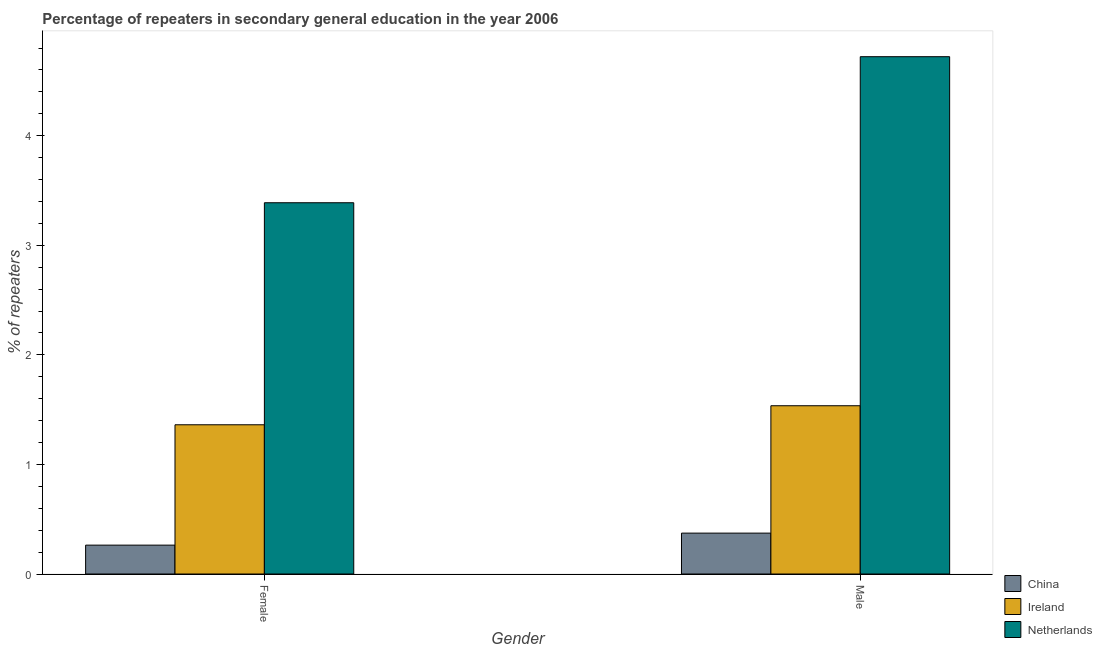How many different coloured bars are there?
Provide a succinct answer. 3. How many groups of bars are there?
Your response must be concise. 2. Are the number of bars on each tick of the X-axis equal?
Make the answer very short. Yes. How many bars are there on the 1st tick from the left?
Your answer should be compact. 3. What is the label of the 1st group of bars from the left?
Your answer should be compact. Female. What is the percentage of male repeaters in China?
Your answer should be very brief. 0.37. Across all countries, what is the maximum percentage of male repeaters?
Ensure brevity in your answer.  4.72. Across all countries, what is the minimum percentage of male repeaters?
Keep it short and to the point. 0.37. What is the total percentage of male repeaters in the graph?
Ensure brevity in your answer.  6.63. What is the difference between the percentage of female repeaters in China and that in Netherlands?
Offer a very short reply. -3.12. What is the difference between the percentage of female repeaters in China and the percentage of male repeaters in Ireland?
Your answer should be very brief. -1.27. What is the average percentage of male repeaters per country?
Give a very brief answer. 2.21. What is the difference between the percentage of male repeaters and percentage of female repeaters in China?
Your answer should be compact. 0.11. In how many countries, is the percentage of male repeaters greater than 0.8 %?
Keep it short and to the point. 2. What is the ratio of the percentage of male repeaters in Netherlands to that in Ireland?
Give a very brief answer. 3.07. Is the percentage of male repeaters in Netherlands less than that in Ireland?
Your response must be concise. No. What does the 1st bar from the right in Male represents?
Make the answer very short. Netherlands. What is the difference between two consecutive major ticks on the Y-axis?
Offer a terse response. 1. Are the values on the major ticks of Y-axis written in scientific E-notation?
Make the answer very short. No. How many legend labels are there?
Your response must be concise. 3. What is the title of the graph?
Your response must be concise. Percentage of repeaters in secondary general education in the year 2006. What is the label or title of the Y-axis?
Your answer should be very brief. % of repeaters. What is the % of repeaters of China in Female?
Offer a terse response. 0.26. What is the % of repeaters in Ireland in Female?
Provide a short and direct response. 1.36. What is the % of repeaters of Netherlands in Female?
Provide a short and direct response. 3.39. What is the % of repeaters in China in Male?
Ensure brevity in your answer.  0.37. What is the % of repeaters in Ireland in Male?
Keep it short and to the point. 1.54. What is the % of repeaters in Netherlands in Male?
Your response must be concise. 4.72. Across all Gender, what is the maximum % of repeaters in China?
Ensure brevity in your answer.  0.37. Across all Gender, what is the maximum % of repeaters in Ireland?
Your response must be concise. 1.54. Across all Gender, what is the maximum % of repeaters in Netherlands?
Ensure brevity in your answer.  4.72. Across all Gender, what is the minimum % of repeaters of China?
Provide a short and direct response. 0.26. Across all Gender, what is the minimum % of repeaters of Ireland?
Offer a terse response. 1.36. Across all Gender, what is the minimum % of repeaters of Netherlands?
Ensure brevity in your answer.  3.39. What is the total % of repeaters of China in the graph?
Your response must be concise. 0.64. What is the total % of repeaters of Ireland in the graph?
Keep it short and to the point. 2.9. What is the total % of repeaters of Netherlands in the graph?
Provide a short and direct response. 8.11. What is the difference between the % of repeaters of China in Female and that in Male?
Ensure brevity in your answer.  -0.11. What is the difference between the % of repeaters in Ireland in Female and that in Male?
Make the answer very short. -0.17. What is the difference between the % of repeaters in Netherlands in Female and that in Male?
Your answer should be very brief. -1.33. What is the difference between the % of repeaters of China in Female and the % of repeaters of Ireland in Male?
Your response must be concise. -1.27. What is the difference between the % of repeaters of China in Female and the % of repeaters of Netherlands in Male?
Your response must be concise. -4.46. What is the difference between the % of repeaters in Ireland in Female and the % of repeaters in Netherlands in Male?
Your response must be concise. -3.36. What is the average % of repeaters of China per Gender?
Keep it short and to the point. 0.32. What is the average % of repeaters of Ireland per Gender?
Provide a succinct answer. 1.45. What is the average % of repeaters of Netherlands per Gender?
Your answer should be compact. 4.05. What is the difference between the % of repeaters in China and % of repeaters in Ireland in Female?
Make the answer very short. -1.1. What is the difference between the % of repeaters in China and % of repeaters in Netherlands in Female?
Provide a succinct answer. -3.12. What is the difference between the % of repeaters in Ireland and % of repeaters in Netherlands in Female?
Your response must be concise. -2.03. What is the difference between the % of repeaters of China and % of repeaters of Ireland in Male?
Offer a terse response. -1.16. What is the difference between the % of repeaters in China and % of repeaters in Netherlands in Male?
Make the answer very short. -4.35. What is the difference between the % of repeaters in Ireland and % of repeaters in Netherlands in Male?
Provide a succinct answer. -3.19. What is the ratio of the % of repeaters in China in Female to that in Male?
Provide a short and direct response. 0.71. What is the ratio of the % of repeaters in Ireland in Female to that in Male?
Your answer should be compact. 0.89. What is the ratio of the % of repeaters in Netherlands in Female to that in Male?
Provide a short and direct response. 0.72. What is the difference between the highest and the second highest % of repeaters of China?
Your answer should be compact. 0.11. What is the difference between the highest and the second highest % of repeaters in Ireland?
Keep it short and to the point. 0.17. What is the difference between the highest and the second highest % of repeaters in Netherlands?
Ensure brevity in your answer.  1.33. What is the difference between the highest and the lowest % of repeaters in China?
Your response must be concise. 0.11. What is the difference between the highest and the lowest % of repeaters of Ireland?
Offer a terse response. 0.17. What is the difference between the highest and the lowest % of repeaters of Netherlands?
Provide a short and direct response. 1.33. 